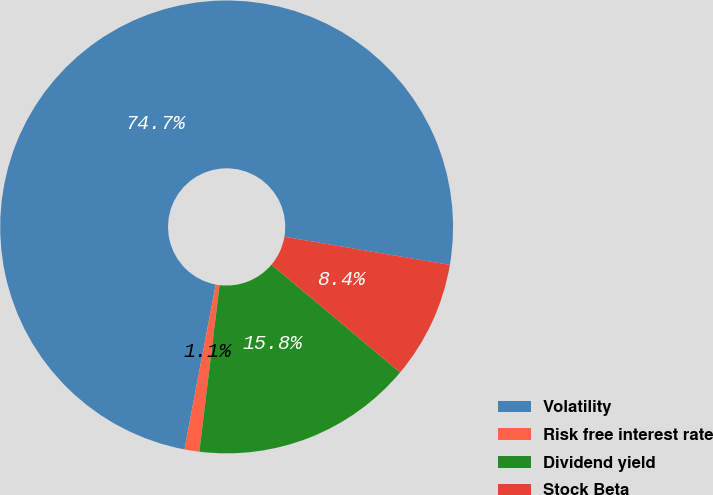Convert chart. <chart><loc_0><loc_0><loc_500><loc_500><pie_chart><fcel>Volatility<fcel>Risk free interest rate<fcel>Dividend yield<fcel>Stock Beta<nl><fcel>74.7%<fcel>1.06%<fcel>15.81%<fcel>8.43%<nl></chart> 